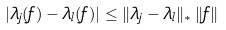Convert formula to latex. <formula><loc_0><loc_0><loc_500><loc_500>| \lambda _ { j } ( f ) - \lambda _ { l } ( f ) | \leq \| \lambda _ { j } - \lambda _ { l } \| _ { * } \, \| f \|</formula> 